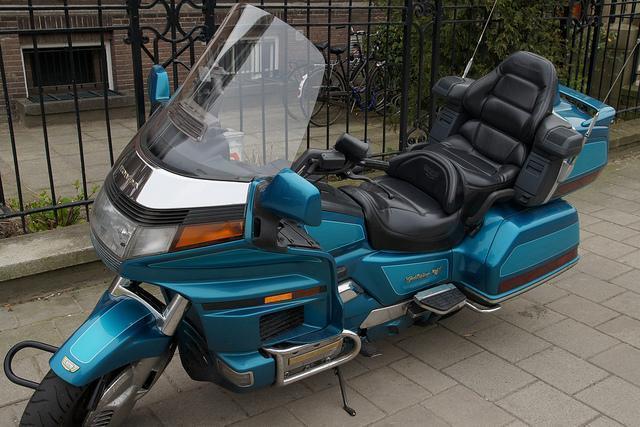How many people can ride this motorcycle at a time?
Select the accurate answer and provide explanation: 'Answer: answer
Rationale: rationale.'
Options: Four, two, three, one. Answer: two.
Rationale: There are two seats and seat backs on the motorcycle that apply that two could ride simultaneously. 